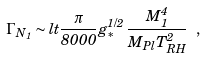Convert formula to latex. <formula><loc_0><loc_0><loc_500><loc_500>\Gamma _ { N _ { 1 } } \sim l t \frac { \pi } { 8 0 0 0 } \, g _ { * } ^ { 1 / 2 } \, \frac { M _ { 1 } ^ { 4 } } { M _ { P l } T _ { R H } ^ { 2 } } \ ,</formula> 